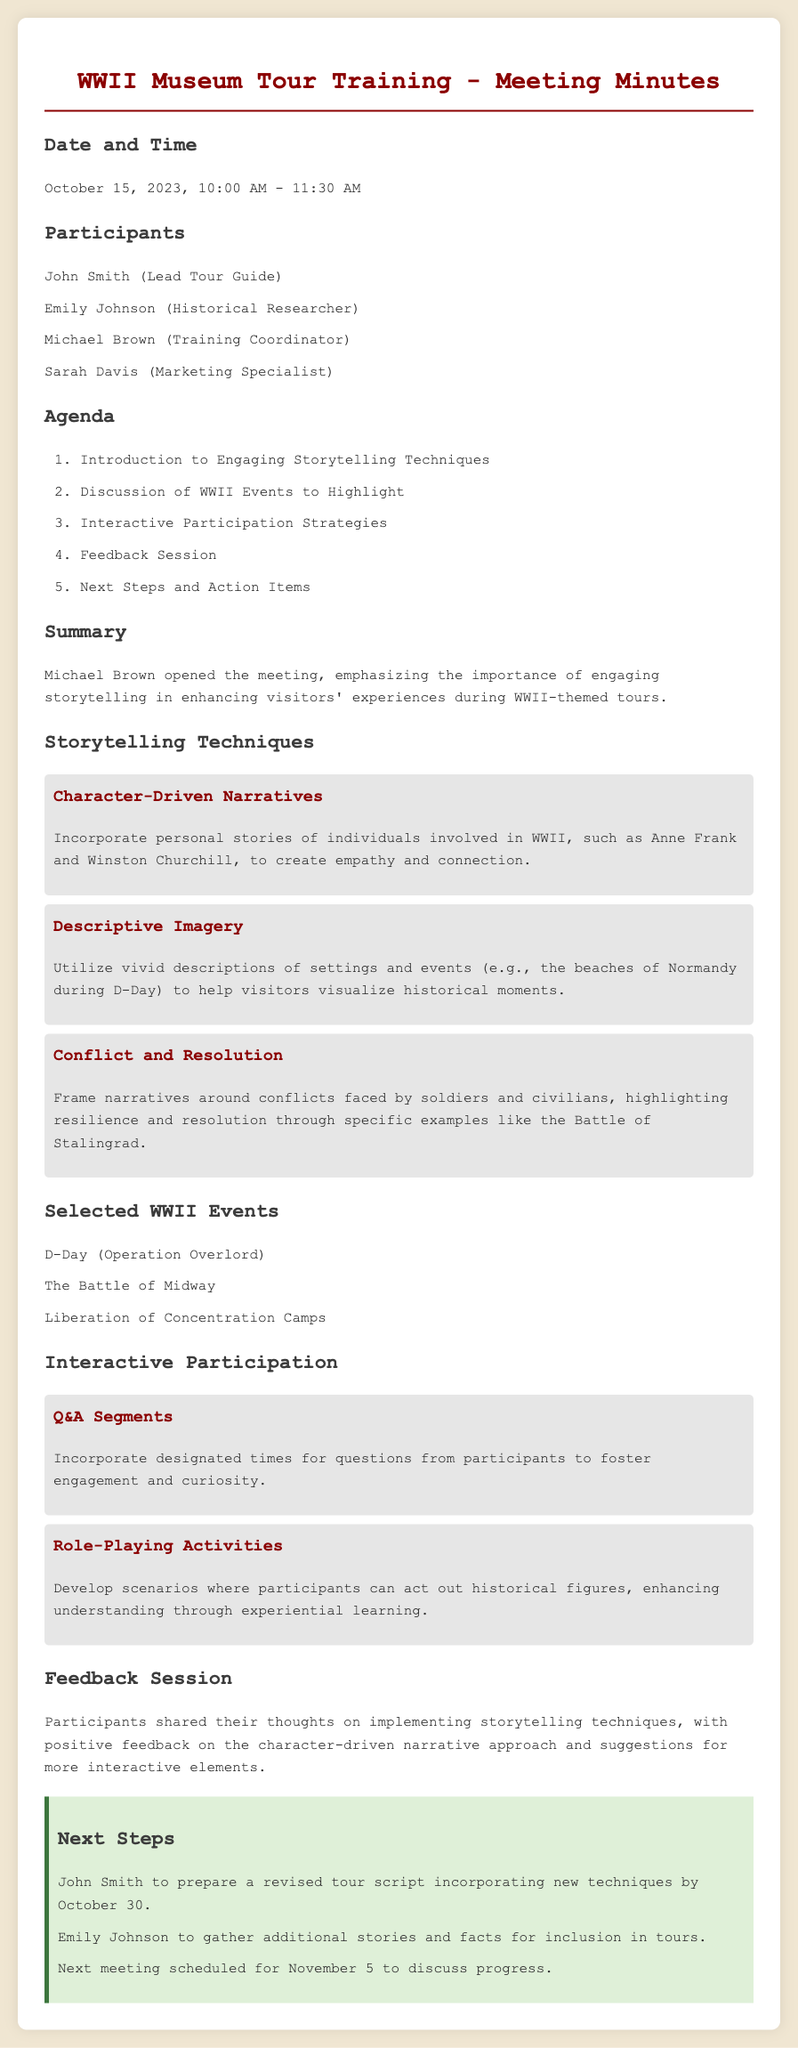What date did the meeting occur? The document specifies that the meeting took place on October 15, 2023.
Answer: October 15, 2023 Who is the Lead Tour Guide? The list of participants identifies John Smith as the Lead Tour Guide.
Answer: John Smith What technique involves using personal stories of WWII individuals? The meeting minutes describe "Character-Driven Narratives" as a technique involving personal stories.
Answer: Character-Driven Narratives Which WWII event is the first listed for discussion? The document lists D-Day (Operation Overlord) as the first event to highlight in tours.
Answer: D-Day (Operation Overlord) What role does Michael Brown hold? In the participants' section, Michael Brown is noted as the Training Coordinator.
Answer: Training Coordinator What type of interactive strategy includes questions from participants? The document mentions "Q&A Segments" as an interactive participation strategy.
Answer: Q&A Segments What is the purpose of the next meeting scheduled for November 5? The next meeting aims to discuss progress on implementing the new techniques.
Answer: Discuss progress Which storytelling technique was positively received during the feedback session? Participants provided positive feedback on the character-driven narrative approach.
Answer: Character-Driven Narrative What is one action item for John Smith? John Smith is tasked with preparing a revised tour script incorporating new techniques.
Answer: Prepare a revised tour script 